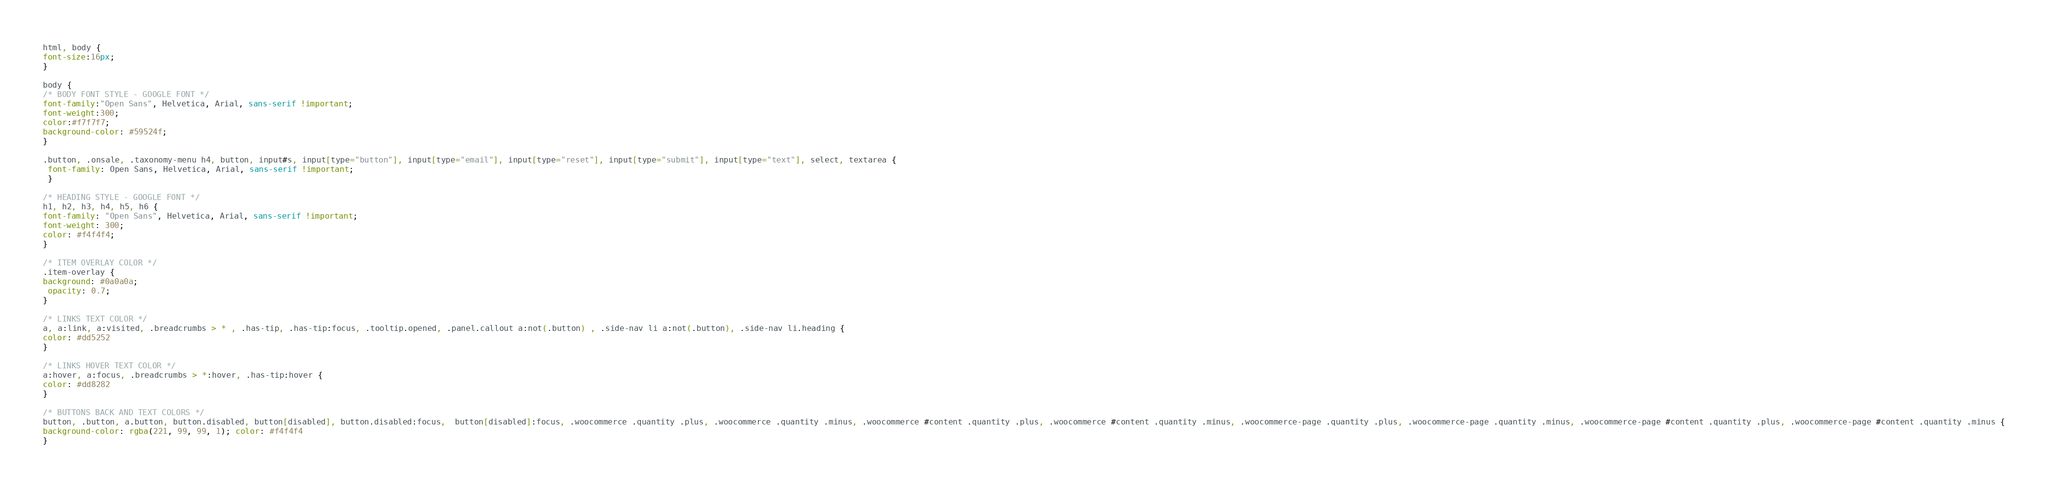Convert code to text. <code><loc_0><loc_0><loc_500><loc_500><_CSS_>html, body { 
font-size:16px;
}

body { 
/* BODY FONT STYLE - GOOGLE FONT */
font-family:"Open Sans", Helvetica, Arial, sans-serif !important;
font-weight:300;
color:#f7f7f7;
background-color: #59524f;
}

.button, .onsale, .taxonomy-menu h4, button, input#s, input[type="button"], input[type="email"], input[type="reset"], input[type="submit"], input[type="text"], select, textarea { 
 font-family: Open Sans, Helvetica, Arial, sans-serif !important;
 }

/* HEADING STYLE - GOOGLE FONT */
h1, h2, h3, h4, h5, h6 { 
font-family: "Open Sans", Helvetica, Arial, sans-serif !important;
font-weight: 300;
color: #f4f4f4;
}

/* ITEM OVERLAY COLOR */
.item-overlay { 
background: #0a0a0a; 
 opacity: 0.7;
}

/* LINKS TEXT COLOR */
a, a:link, a:visited, .breadcrumbs > * , .has-tip, .has-tip:focus, .tooltip.opened, .panel.callout a:not(.button) , .side-nav li a:not(.button), .side-nav li.heading {
color: #dd5252 
}

/* LINKS HOVER TEXT COLOR */
a:hover, a:focus, .breadcrumbs > *:hover, .has-tip:hover { 
color: #dd8282 
}

/* BUTTONS BACK AND TEXT COLORS */
button, .button, a.button, button.disabled, button[disabled], button.disabled:focus,  button[disabled]:focus, .woocommerce .quantity .plus, .woocommerce .quantity .minus, .woocommerce #content .quantity .plus, .woocommerce #content .quantity .minus, .woocommerce-page .quantity .plus, .woocommerce-page .quantity .minus, .woocommerce-page #content .quantity .plus, .woocommerce-page #content .quantity .minus {
background-color: rgba(221, 99, 99, 1); color: #f4f4f4
}
</code> 